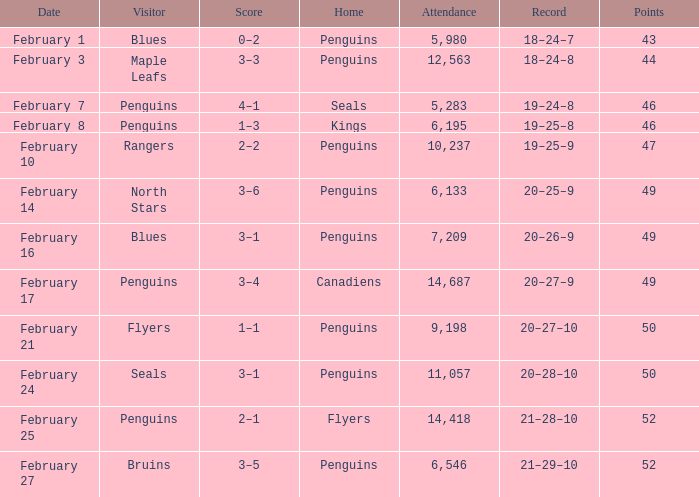Home of kings had what score? 1–3. 